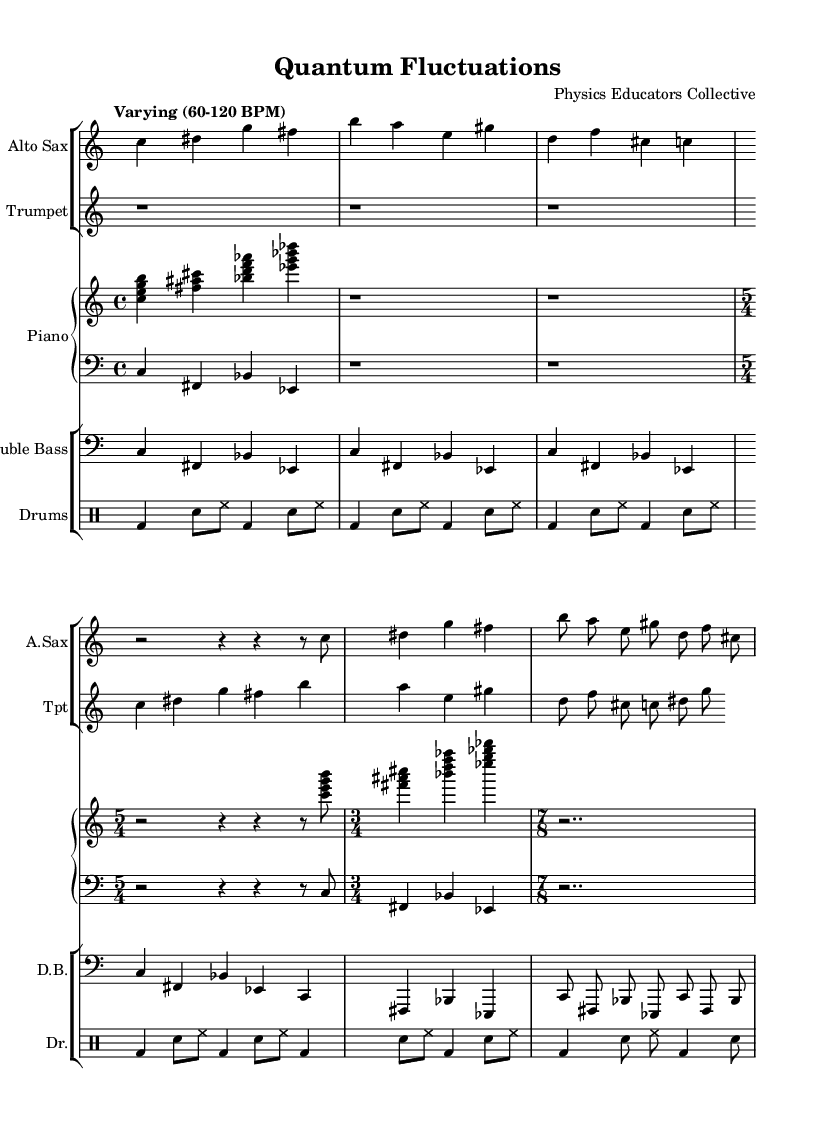What is the time signature of the first section? The first section has a time signature of 4/4, as indicated by the first numeral in the opening measure.
Answer: 4/4 What is the tempo indication in the score? The tempo is described as "Varying (60-120 BPM)," which suggests that the performance speed can fluctuate within that range.
Answer: Varying (60-120 BPM) How many measures are there in the saxophone part? To find this, you would count the measures in the saxophone part; there are eight measures total across different time signatures.
Answer: 8 What time signature has the longest measure in the score? Upon examining the score, the time signature with the longest measure is 7/8, which features the different rhythmic feel compared to the others.
Answer: 7/8 Which instrument plays the lowest register note? The lowest register note in the score is played by the Double Bass, which is indicated in the bass clef and plays pitches lower than those found in other instruments.
Answer: Double Bass How does the drum pattern change in the 5/4 section? In the 5/4 section, the drum pattern introduces a longer sequence characterized by a combination of bass drums and snare hits, creating a more complex rhythmic texture.
Answer: More complex rhythmic texture What is the overall characteristic of the chord progressions in the piano part? The chord progressions in the piano part contain clustered voicings, which reflect an avant-garde style that aligns with the theme of unpredictability, often seen in avant-garde jazz.
Answer: Clustered voicings 